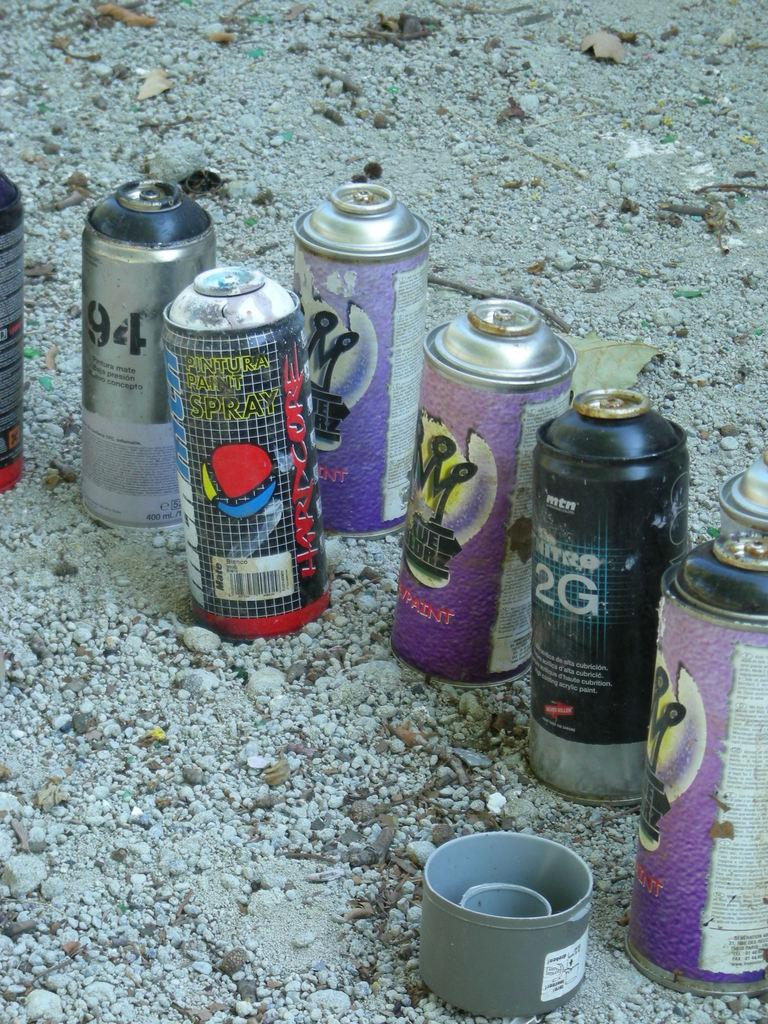<image>
Share a concise interpretation of the image provided. a bottle that has 2G written on the front 